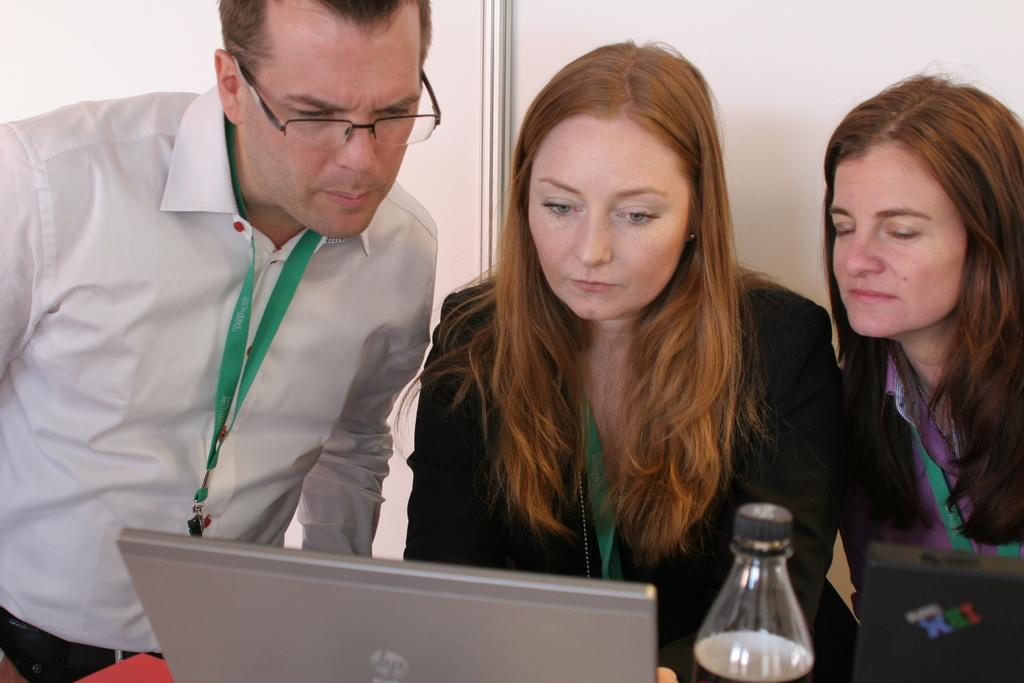How many people are present in the image? There are three people in the image. What are the people wearing that can be seen in the image? The people are wearing tags. What electronic device is visible in the image? There is a laptop in the image. What type of object is black in the image? There is a black object in the image. What beverage container is present in the image? There is a bottle in the image. What can be seen in the background of the image? There is a wall in the background of the image. What hour is depicted on the clock tower in the image? There is no clock tower present in the image, so it is not possible to determine the hour. 